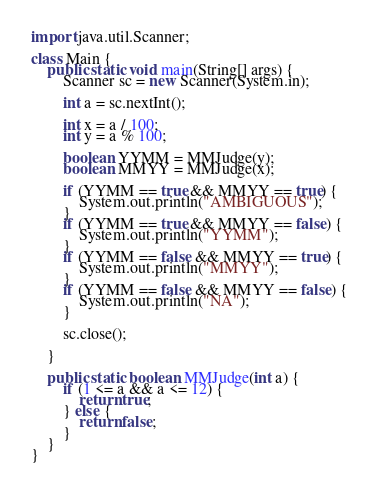<code> <loc_0><loc_0><loc_500><loc_500><_Java_>import java.util.Scanner;

class Main {
    public static void main(String[] args) {
        Scanner sc = new Scanner(System.in);

        int a = sc.nextInt();

        int x = a / 100;
        int y = a % 100;

        boolean YYMM = MMJudge(y);
        boolean MMYY = MMJudge(x);

        if (YYMM == true && MMYY == true) {
            System.out.println("AMBIGUOUS");
        }
        if (YYMM == true && MMYY == false) {
            System.out.println("YYMM");
        }
        if (YYMM == false && MMYY == true) {
            System.out.println("MMYY");
        }
        if (YYMM == false && MMYY == false) {
            System.out.println("NA");
        }

        sc.close();

    }

    public static boolean MMJudge(int a) {
        if (1 <= a && a <= 12) {
            return true;
        } else {
            return false;
        }
    }
}</code> 